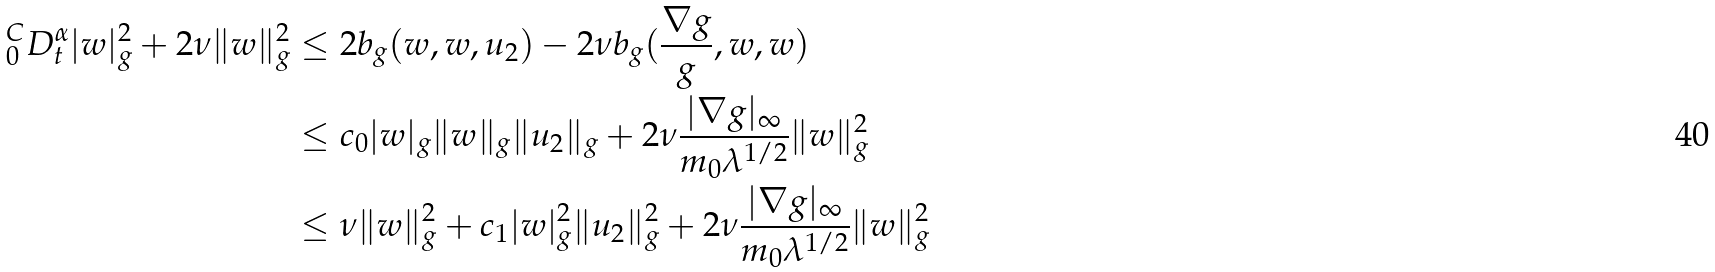<formula> <loc_0><loc_0><loc_500><loc_500>\, _ { 0 } ^ { C } D _ { t } ^ { \alpha } | w | _ { g } ^ { 2 } + 2 \nu \| w \| _ { g } ^ { 2 } & \leq 2 b _ { g } ( w , w , u _ { 2 } ) - 2 \nu b _ { g } ( \frac { \nabla g } { g } , w , w ) \\ & \leq c _ { 0 } | w | _ { g } \| w \| _ { g } \| u _ { 2 } \| _ { g } + 2 \nu \frac { | \nabla g | _ { \infty } } { m _ { 0 } \lambda ^ { 1 / 2 } } \| w \| _ { g } ^ { 2 } \\ & \leq \nu \| w \| _ { g } ^ { 2 } + c _ { 1 } | w | ^ { 2 } _ { g } \| u _ { 2 } \| ^ { 2 } _ { g } + 2 \nu \frac { | \nabla g | _ { \infty } } { m _ { 0 } \lambda ^ { 1 / 2 } } \| w \| _ { g } ^ { 2 }</formula> 